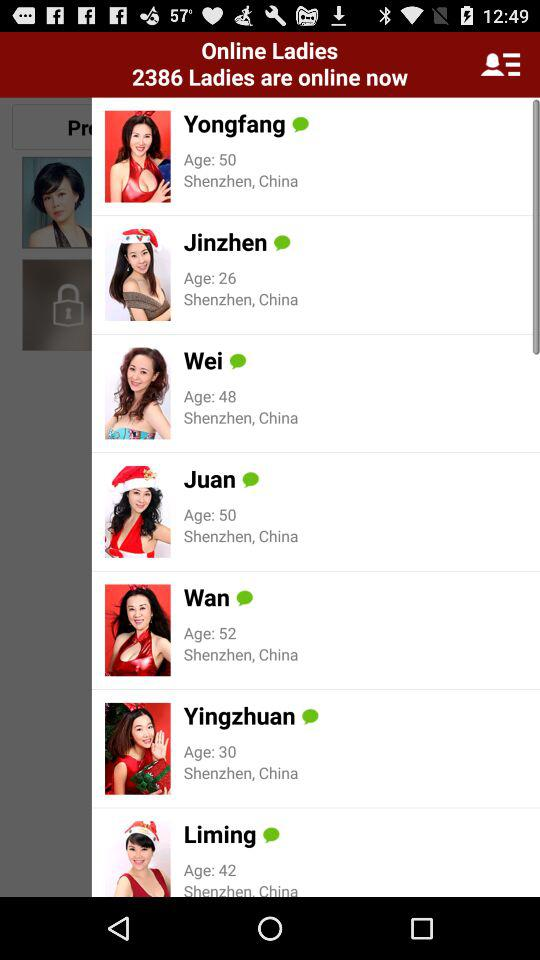What is the location of Wan? The location of Wan is "Shenzhen, China". 